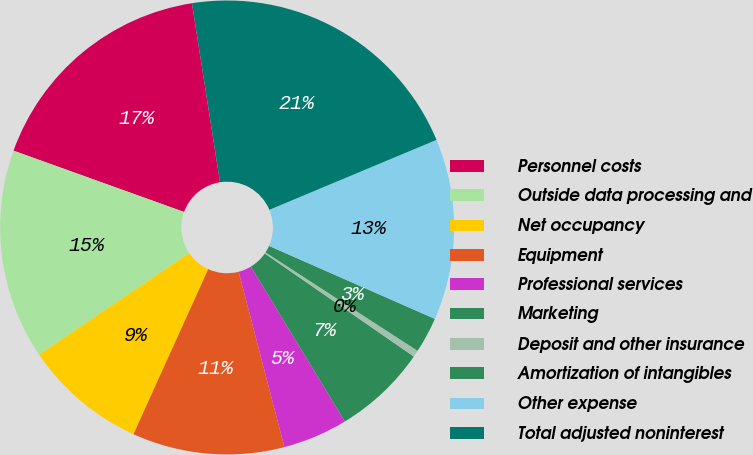Convert chart. <chart><loc_0><loc_0><loc_500><loc_500><pie_chart><fcel>Personnel costs<fcel>Outside data processing and<fcel>Net occupancy<fcel>Equipment<fcel>Professional services<fcel>Marketing<fcel>Deposit and other insurance<fcel>Amortization of intangibles<fcel>Other expense<fcel>Total adjusted noninterest<nl><fcel>17.03%<fcel>14.96%<fcel>8.76%<fcel>10.83%<fcel>4.62%<fcel>6.69%<fcel>0.48%<fcel>2.55%<fcel>12.9%<fcel>21.17%<nl></chart> 